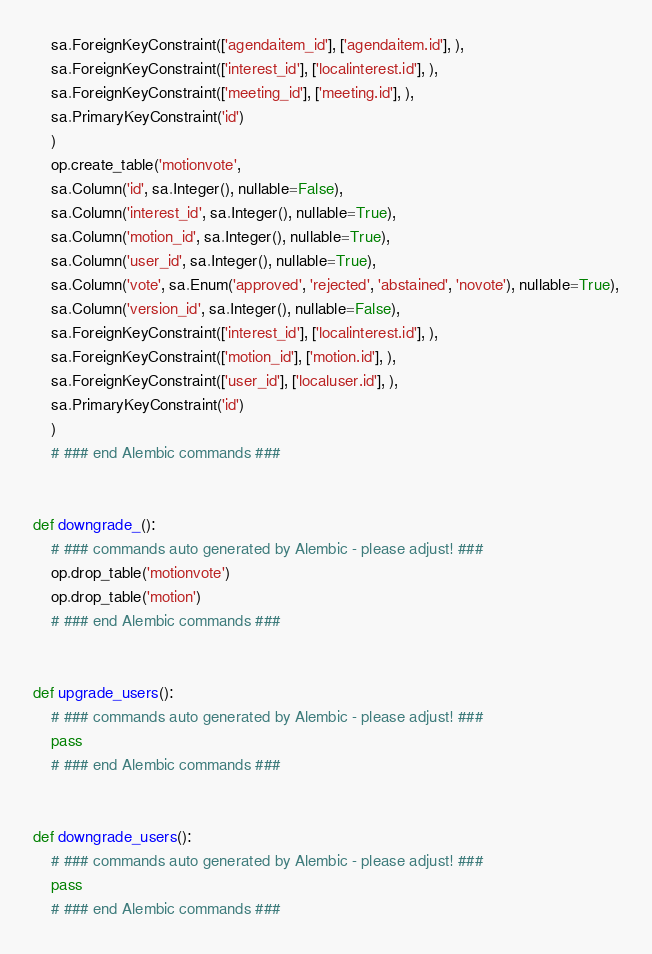<code> <loc_0><loc_0><loc_500><loc_500><_Python_>    sa.ForeignKeyConstraint(['agendaitem_id'], ['agendaitem.id'], ),
    sa.ForeignKeyConstraint(['interest_id'], ['localinterest.id'], ),
    sa.ForeignKeyConstraint(['meeting_id'], ['meeting.id'], ),
    sa.PrimaryKeyConstraint('id')
    )
    op.create_table('motionvote',
    sa.Column('id', sa.Integer(), nullable=False),
    sa.Column('interest_id', sa.Integer(), nullable=True),
    sa.Column('motion_id', sa.Integer(), nullable=True),
    sa.Column('user_id', sa.Integer(), nullable=True),
    sa.Column('vote', sa.Enum('approved', 'rejected', 'abstained', 'novote'), nullable=True),
    sa.Column('version_id', sa.Integer(), nullable=False),
    sa.ForeignKeyConstraint(['interest_id'], ['localinterest.id'], ),
    sa.ForeignKeyConstraint(['motion_id'], ['motion.id'], ),
    sa.ForeignKeyConstraint(['user_id'], ['localuser.id'], ),
    sa.PrimaryKeyConstraint('id')
    )
    # ### end Alembic commands ###


def downgrade_():
    # ### commands auto generated by Alembic - please adjust! ###
    op.drop_table('motionvote')
    op.drop_table('motion')
    # ### end Alembic commands ###


def upgrade_users():
    # ### commands auto generated by Alembic - please adjust! ###
    pass
    # ### end Alembic commands ###


def downgrade_users():
    # ### commands auto generated by Alembic - please adjust! ###
    pass
    # ### end Alembic commands ###

</code> 